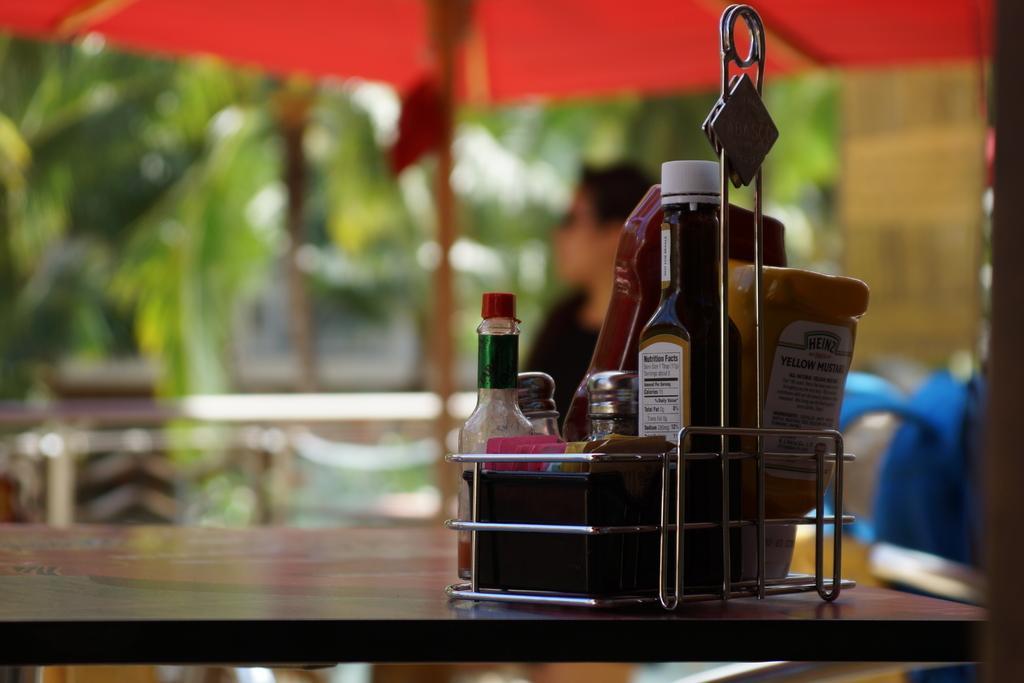Can you describe this image briefly? In this image i can see table, on the table there are some bottles kept on that ,background i can see a red color tent and a person wearing a black color shirt visible and there are some trees visible on the background ,. 